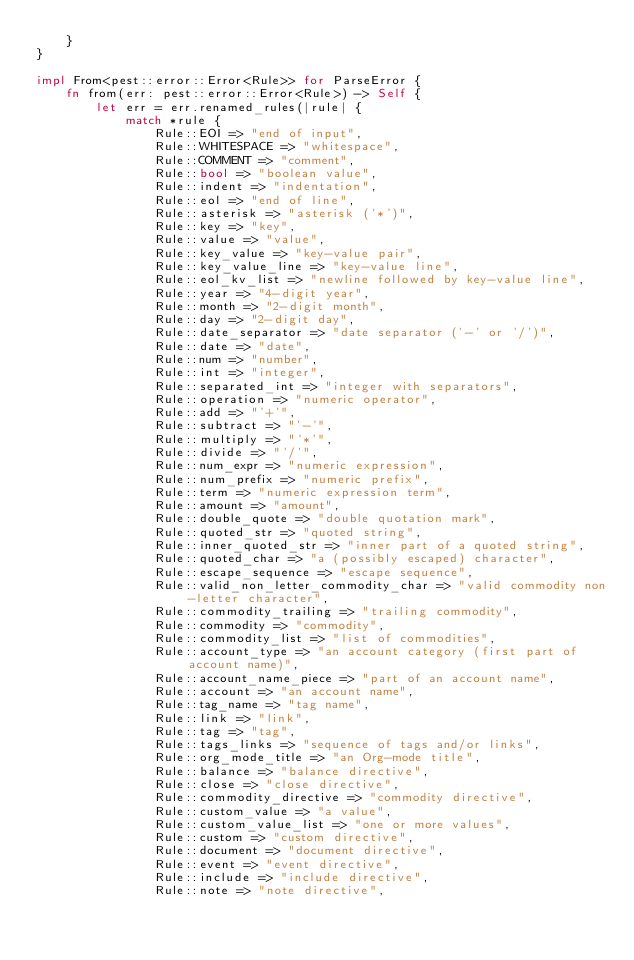Convert code to text. <code><loc_0><loc_0><loc_500><loc_500><_Rust_>    }
}

impl From<pest::error::Error<Rule>> for ParseError {
    fn from(err: pest::error::Error<Rule>) -> Self {
        let err = err.renamed_rules(|rule| {
            match *rule {
                Rule::EOI => "end of input",
                Rule::WHITESPACE => "whitespace",
                Rule::COMMENT => "comment",
                Rule::bool => "boolean value",
                Rule::indent => "indentation",
                Rule::eol => "end of line",
                Rule::asterisk => "asterisk ('*')",
                Rule::key => "key",
                Rule::value => "value",
                Rule::key_value => "key-value pair",
                Rule::key_value_line => "key-value line",
                Rule::eol_kv_list => "newline followed by key-value line",
                Rule::year => "4-digit year",
                Rule::month => "2-digit month",
                Rule::day => "2-digit day",
                Rule::date_separator => "date separator ('-' or '/')",
                Rule::date => "date",
                Rule::num => "number",
                Rule::int => "integer",
                Rule::separated_int => "integer with separators",
                Rule::operation => "numeric operator",
                Rule::add => "'+'",
                Rule::subtract => "'-'",
                Rule::multiply => "'*'",
                Rule::divide => "'/'",
                Rule::num_expr => "numeric expression",
                Rule::num_prefix => "numeric prefix",
                Rule::term => "numeric expression term",
                Rule::amount => "amount",
                Rule::double_quote => "double quotation mark",
                Rule::quoted_str => "quoted string",
                Rule::inner_quoted_str => "inner part of a quoted string",
                Rule::quoted_char => "a (possibly escaped) character",
                Rule::escape_sequence => "escape sequence",
                Rule::valid_non_letter_commodity_char => "valid commodity non-letter character",
                Rule::commodity_trailing => "trailing commodity",
                Rule::commodity => "commodity",
                Rule::commodity_list => "list of commodities",
                Rule::account_type => "an account category (first part of account name)",
                Rule::account_name_piece => "part of an account name",
                Rule::account => "an account name",
                Rule::tag_name => "tag name",
                Rule::link => "link",
                Rule::tag => "tag",
                Rule::tags_links => "sequence of tags and/or links",
                Rule::org_mode_title => "an Org-mode title",
                Rule::balance => "balance directive",
                Rule::close => "close directive",
                Rule::commodity_directive => "commodity directive",
                Rule::custom_value => "a value",
                Rule::custom_value_list => "one or more values",
                Rule::custom => "custom directive",
                Rule::document => "document directive",
                Rule::event => "event directive",
                Rule::include => "include directive",
                Rule::note => "note directive",</code> 